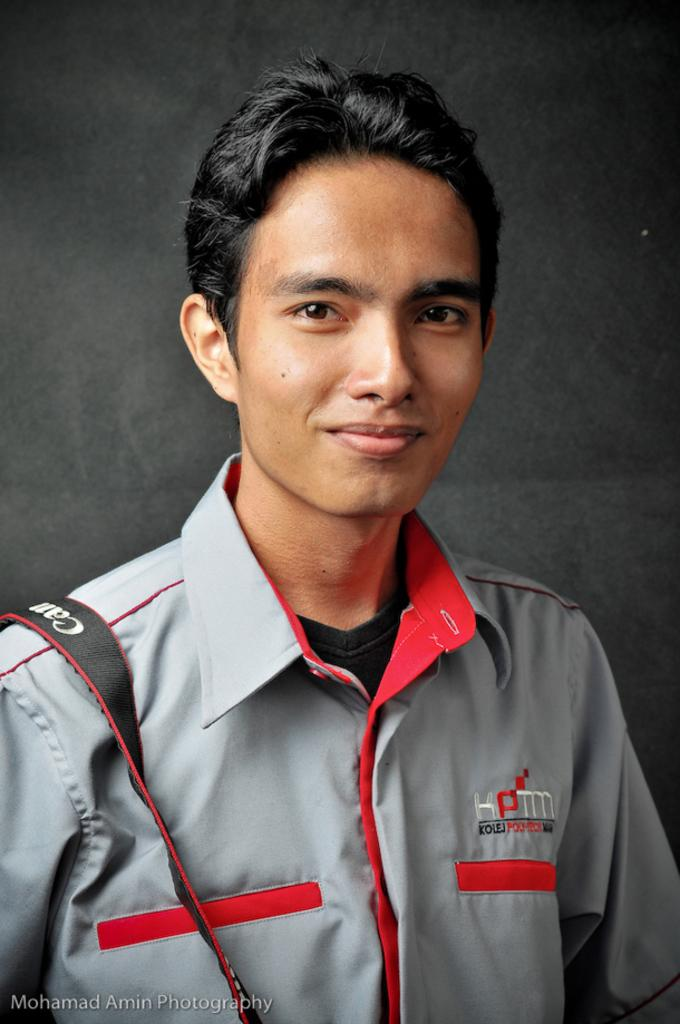What is the main subject of the image? There is a person in the image. What can be seen around the person's shoulder? The person is wearing a camera bag around their shoulder. How many muscles can be seen flexing in the person's finger in the image? There is no visible finger in the image, and therefore no muscles can be seen flexing. 